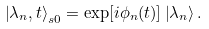<formula> <loc_0><loc_0><loc_500><loc_500>\left | \lambda _ { n } , t \right \rangle _ { s 0 } = \exp [ i \phi _ { n } ( t ) ] \left | \lambda _ { n } \right \rangle .</formula> 